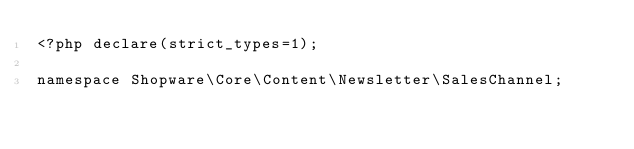Convert code to text. <code><loc_0><loc_0><loc_500><loc_500><_PHP_><?php declare(strict_types=1);

namespace Shopware\Core\Content\Newsletter\SalesChannel;
</code> 